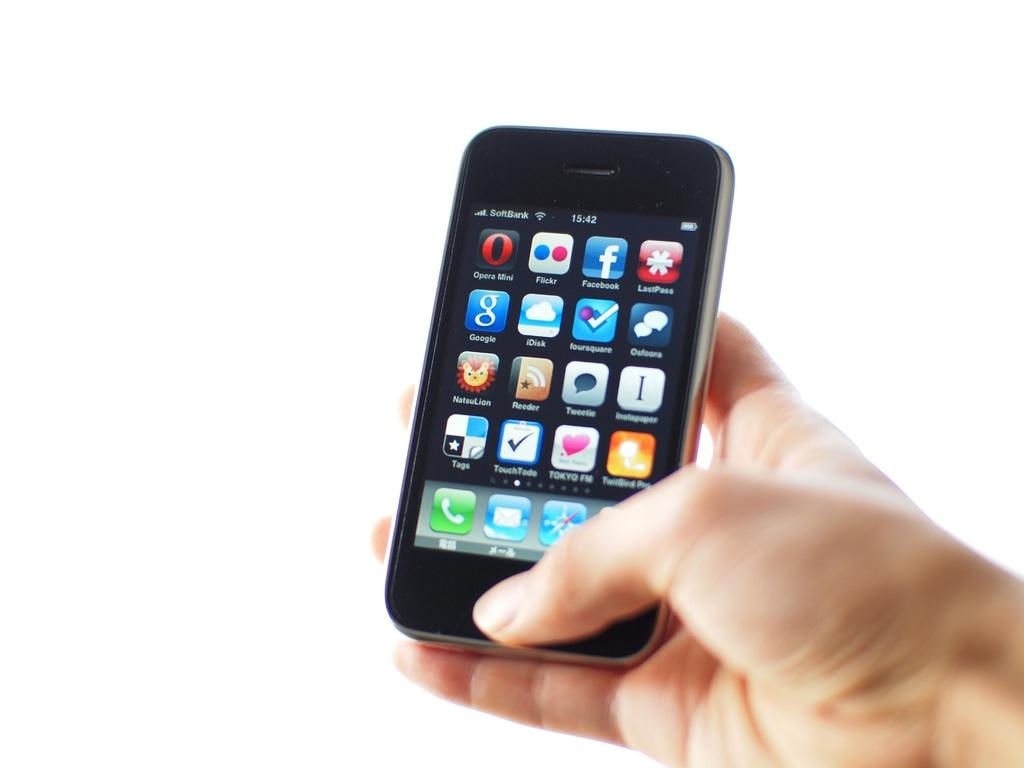<image>
Present a compact description of the photo's key features. Smartphone screen with a Facebook and TOKYO FM app 